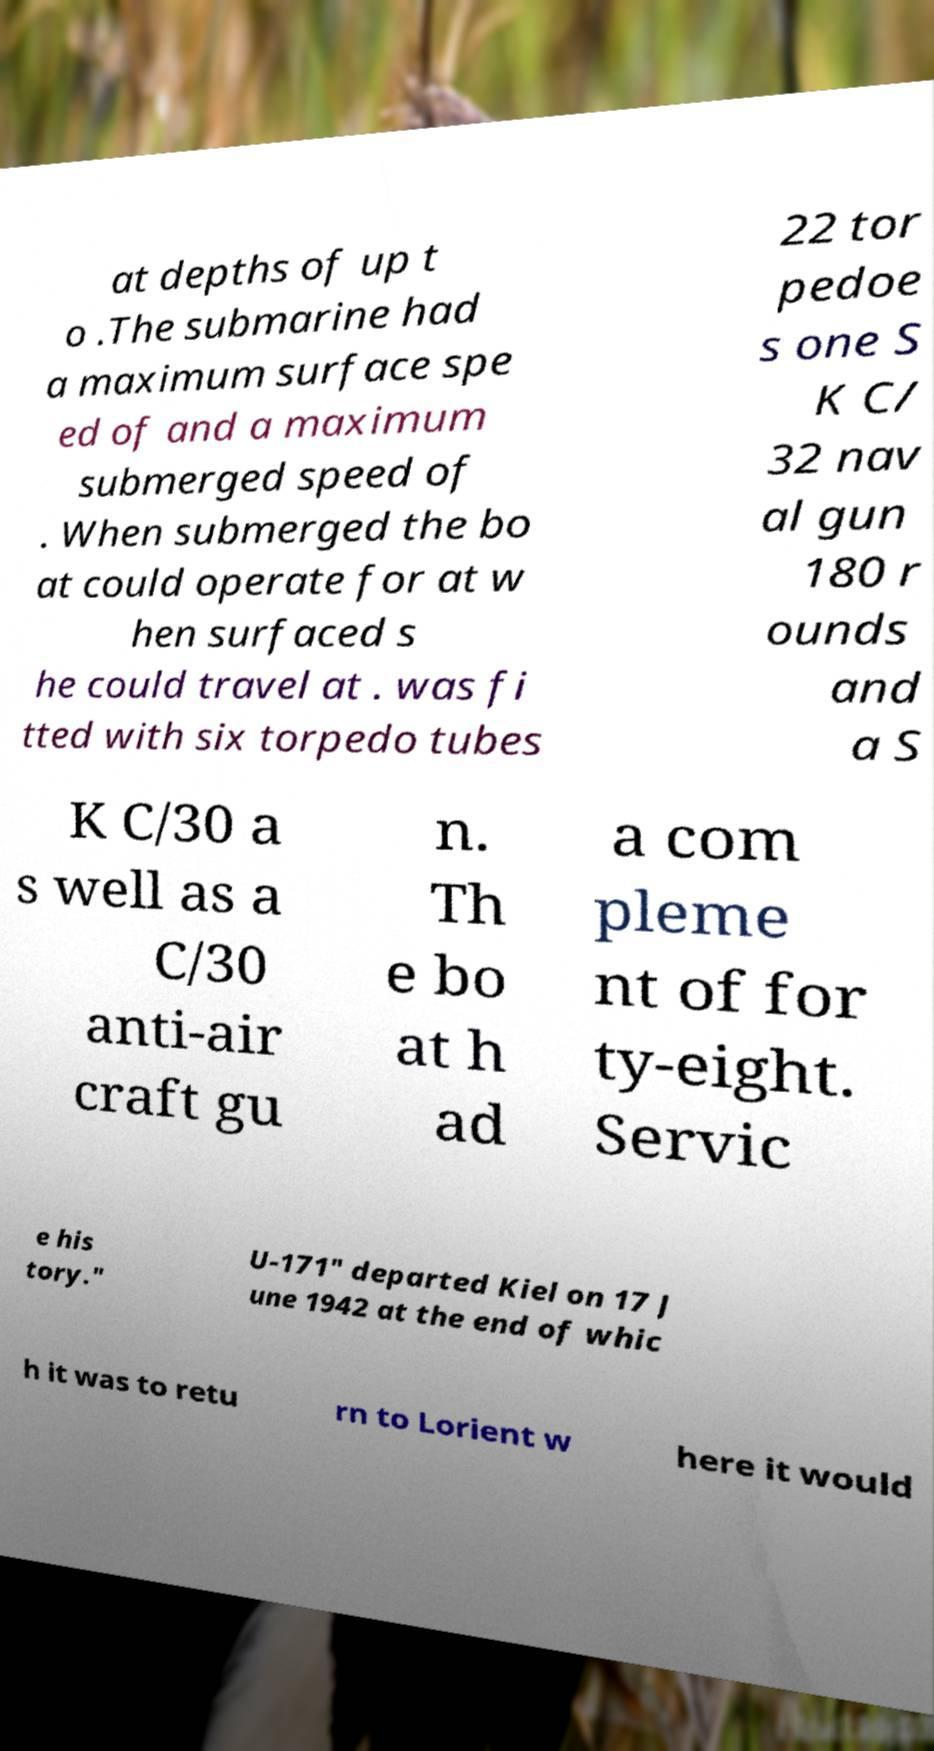Can you read and provide the text displayed in the image?This photo seems to have some interesting text. Can you extract and type it out for me? at depths of up t o .The submarine had a maximum surface spe ed of and a maximum submerged speed of . When submerged the bo at could operate for at w hen surfaced s he could travel at . was fi tted with six torpedo tubes 22 tor pedoe s one S K C/ 32 nav al gun 180 r ounds and a S K C/30 a s well as a C/30 anti-air craft gu n. Th e bo at h ad a com pleme nt of for ty-eight. Servic e his tory." U-171" departed Kiel on 17 J une 1942 at the end of whic h it was to retu rn to Lorient w here it would 